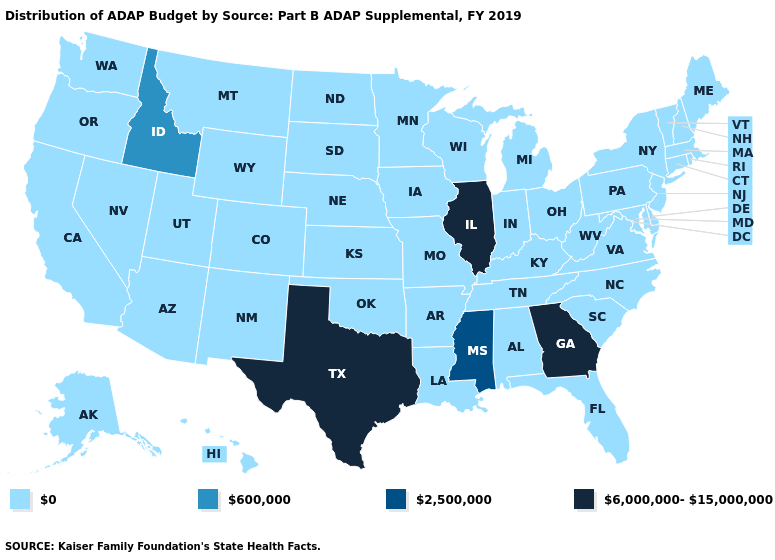What is the value of Nevada?
Answer briefly. 0. What is the value of New York?
Short answer required. 0. Which states have the lowest value in the USA?
Write a very short answer. Alabama, Alaska, Arizona, Arkansas, California, Colorado, Connecticut, Delaware, Florida, Hawaii, Indiana, Iowa, Kansas, Kentucky, Louisiana, Maine, Maryland, Massachusetts, Michigan, Minnesota, Missouri, Montana, Nebraska, Nevada, New Hampshire, New Jersey, New Mexico, New York, North Carolina, North Dakota, Ohio, Oklahoma, Oregon, Pennsylvania, Rhode Island, South Carolina, South Dakota, Tennessee, Utah, Vermont, Virginia, Washington, West Virginia, Wisconsin, Wyoming. What is the highest value in the USA?
Concise answer only. 6,000,000-15,000,000. Among the states that border Idaho , which have the lowest value?
Be succinct. Montana, Nevada, Oregon, Utah, Washington, Wyoming. Name the states that have a value in the range 2,500,000?
Quick response, please. Mississippi. Among the states that border Colorado , which have the highest value?
Concise answer only. Arizona, Kansas, Nebraska, New Mexico, Oklahoma, Utah, Wyoming. What is the value of Colorado?
Write a very short answer. 0. What is the value of Washington?
Be succinct. 0. What is the value of Iowa?
Give a very brief answer. 0. Name the states that have a value in the range 6,000,000-15,000,000?
Concise answer only. Georgia, Illinois, Texas. What is the value of Kentucky?
Be succinct. 0. What is the lowest value in states that border Nevada?
Keep it brief. 0. Does Iowa have the lowest value in the MidWest?
Short answer required. Yes. Name the states that have a value in the range 2,500,000?
Keep it brief. Mississippi. 